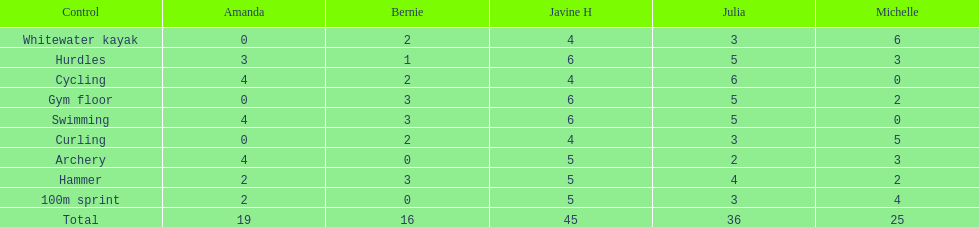State a young lady who reached equal results in cycle racing and bow and arrow competitions. Amanda. 